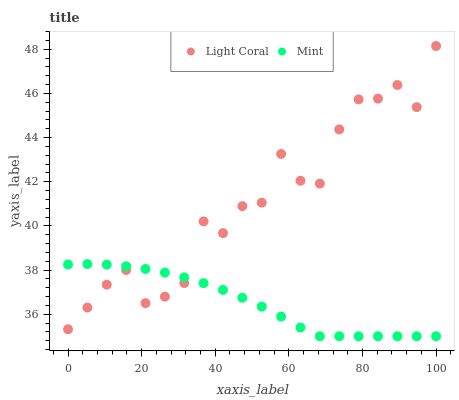Does Mint have the minimum area under the curve?
Answer yes or no. Yes. Does Light Coral have the maximum area under the curve?
Answer yes or no. Yes. Does Mint have the maximum area under the curve?
Answer yes or no. No. Is Mint the smoothest?
Answer yes or no. Yes. Is Light Coral the roughest?
Answer yes or no. Yes. Is Mint the roughest?
Answer yes or no. No. Does Mint have the lowest value?
Answer yes or no. Yes. Does Light Coral have the highest value?
Answer yes or no. Yes. Does Mint have the highest value?
Answer yes or no. No. Does Light Coral intersect Mint?
Answer yes or no. Yes. Is Light Coral less than Mint?
Answer yes or no. No. Is Light Coral greater than Mint?
Answer yes or no. No. 